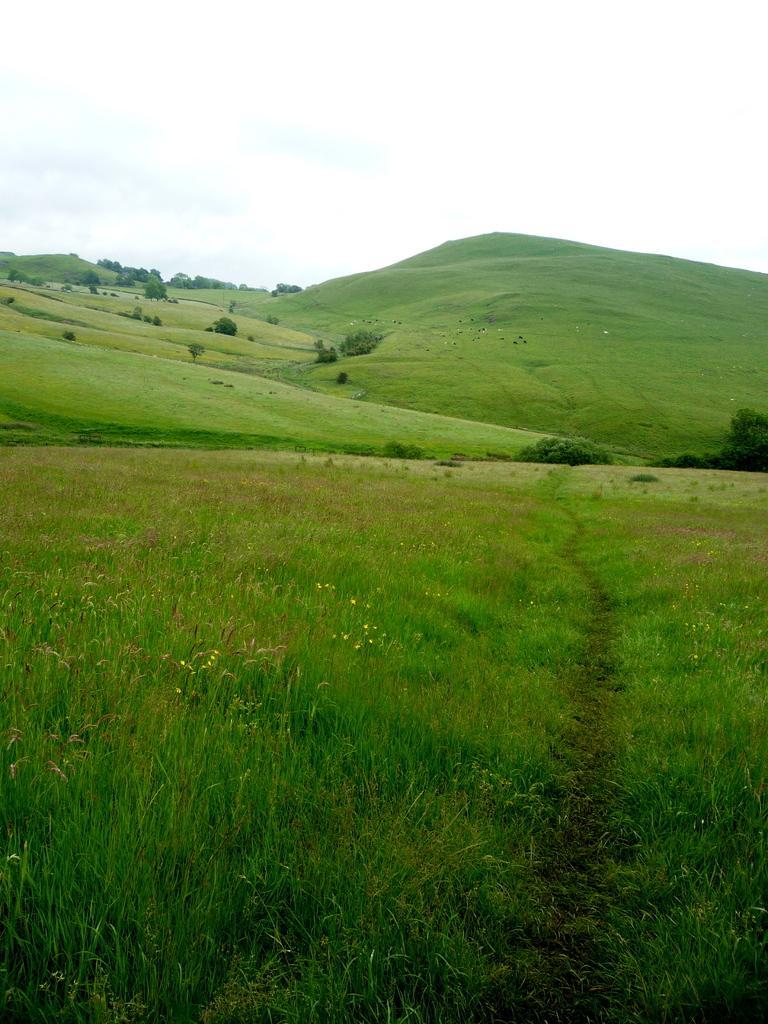Please provide a concise description of this image. In front of the image there are plants and flowers. In the background of the image there is grass on the surface. There are plants, trees. At the top of the image there is sky. 